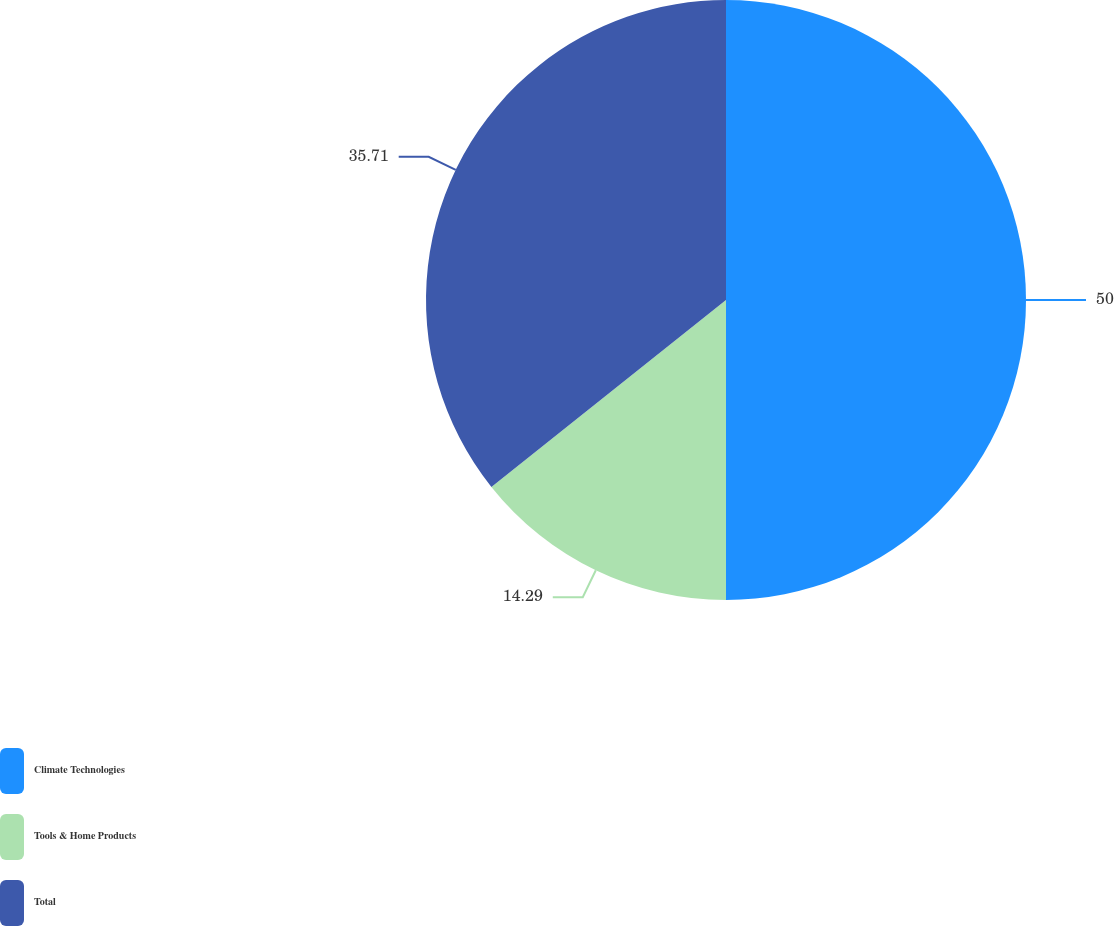Convert chart. <chart><loc_0><loc_0><loc_500><loc_500><pie_chart><fcel>Climate Technologies<fcel>Tools & Home Products<fcel>Total<nl><fcel>50.0%<fcel>14.29%<fcel>35.71%<nl></chart> 